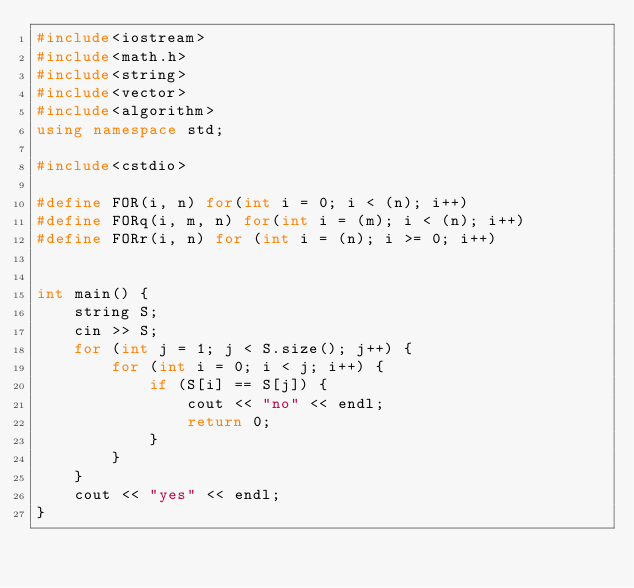Convert code to text. <code><loc_0><loc_0><loc_500><loc_500><_C++_>#include<iostream>
#include<math.h>
#include<string>
#include<vector>
#include<algorithm>
using namespace std;

#include<cstdio>

#define FOR(i, n) for(int i = 0; i < (n); i++)
#define FORq(i, m, n) for(int i = (m); i < (n); i++)
#define FORr(i, n) for (int i = (n); i >= 0; i++)


int main() {
	string S;
	cin >> S;
	for (int j = 1; j < S.size(); j++) {
		for (int i = 0; i < j; i++) {
			if (S[i] == S[j]) {
				cout << "no" << endl;
				return 0;
			}
		}
	}
	cout << "yes" << endl;
}</code> 